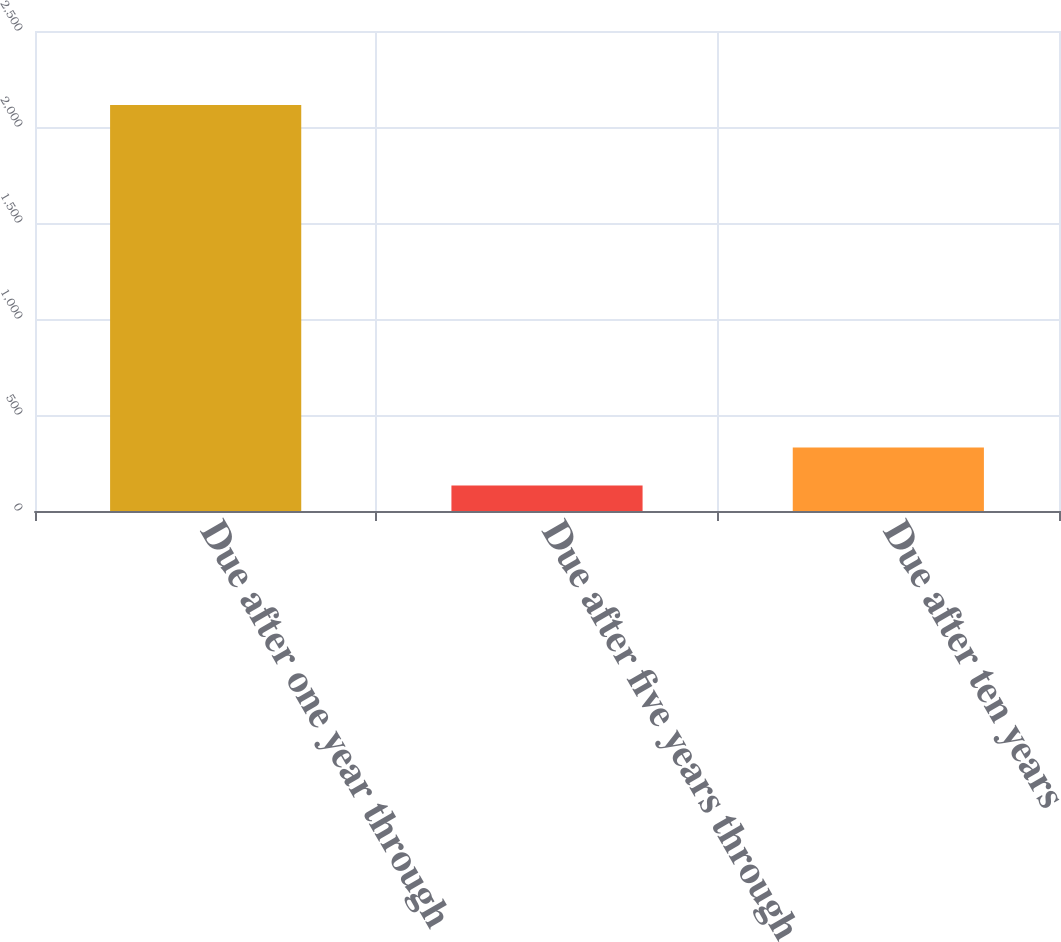<chart> <loc_0><loc_0><loc_500><loc_500><bar_chart><fcel>Due after one year through<fcel>Due after five years through<fcel>Due after ten years<nl><fcel>2115<fcel>133<fcel>331.2<nl></chart> 